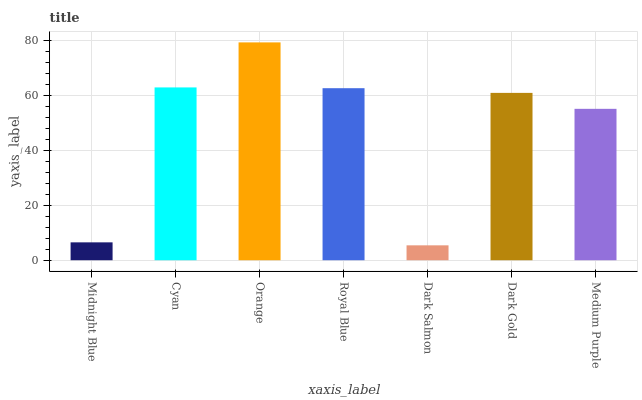Is Cyan the minimum?
Answer yes or no. No. Is Cyan the maximum?
Answer yes or no. No. Is Cyan greater than Midnight Blue?
Answer yes or no. Yes. Is Midnight Blue less than Cyan?
Answer yes or no. Yes. Is Midnight Blue greater than Cyan?
Answer yes or no. No. Is Cyan less than Midnight Blue?
Answer yes or no. No. Is Dark Gold the high median?
Answer yes or no. Yes. Is Dark Gold the low median?
Answer yes or no. Yes. Is Cyan the high median?
Answer yes or no. No. Is Medium Purple the low median?
Answer yes or no. No. 